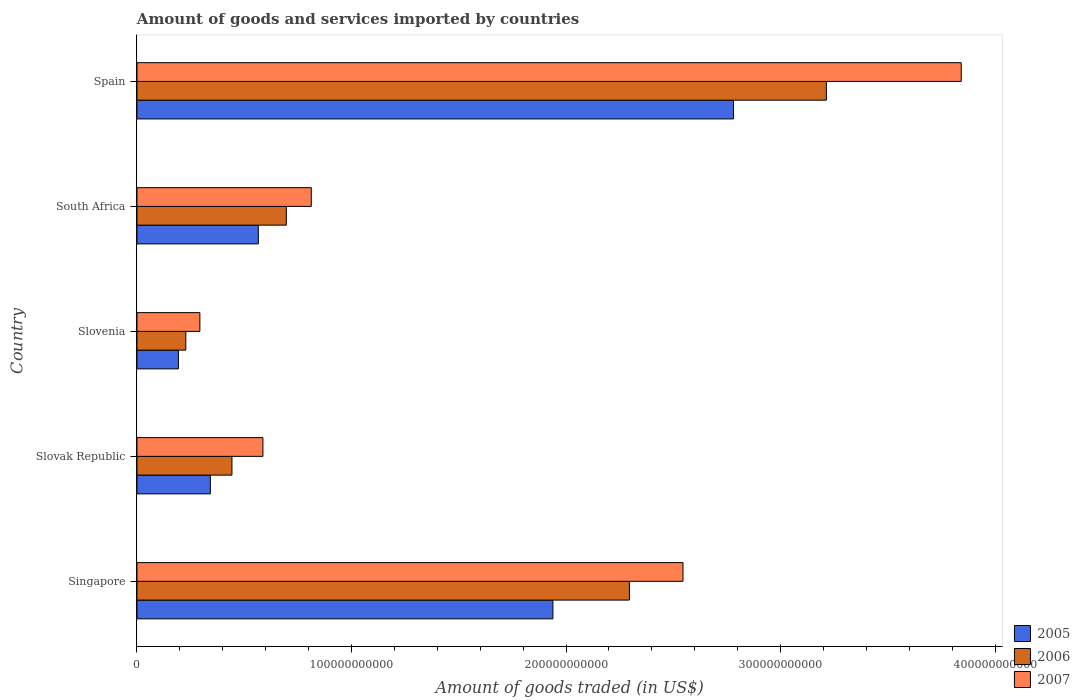How many different coloured bars are there?
Your answer should be compact. 3. Are the number of bars per tick equal to the number of legend labels?
Give a very brief answer. Yes. Are the number of bars on each tick of the Y-axis equal?
Keep it short and to the point. Yes. How many bars are there on the 4th tick from the top?
Offer a very short reply. 3. How many bars are there on the 4th tick from the bottom?
Keep it short and to the point. 3. What is the label of the 2nd group of bars from the top?
Provide a short and direct response. South Africa. In how many cases, is the number of bars for a given country not equal to the number of legend labels?
Offer a terse response. 0. What is the total amount of goods and services imported in 2007 in South Africa?
Provide a short and direct response. 8.13e+1. Across all countries, what is the maximum total amount of goods and services imported in 2005?
Provide a short and direct response. 2.78e+11. Across all countries, what is the minimum total amount of goods and services imported in 2006?
Offer a very short reply. 2.28e+1. In which country was the total amount of goods and services imported in 2005 maximum?
Make the answer very short. Spain. In which country was the total amount of goods and services imported in 2006 minimum?
Provide a succinct answer. Slovenia. What is the total total amount of goods and services imported in 2007 in the graph?
Your answer should be compact. 8.08e+11. What is the difference between the total amount of goods and services imported in 2006 in Slovak Republic and that in South Africa?
Keep it short and to the point. -2.53e+1. What is the difference between the total amount of goods and services imported in 2005 in Slovak Republic and the total amount of goods and services imported in 2007 in South Africa?
Your answer should be compact. -4.70e+1. What is the average total amount of goods and services imported in 2005 per country?
Your answer should be compact. 1.16e+11. What is the difference between the total amount of goods and services imported in 2005 and total amount of goods and services imported in 2006 in Singapore?
Keep it short and to the point. -3.57e+1. In how many countries, is the total amount of goods and services imported in 2006 greater than 120000000000 US$?
Give a very brief answer. 2. What is the ratio of the total amount of goods and services imported in 2006 in Slovenia to that in South Africa?
Provide a short and direct response. 0.33. What is the difference between the highest and the second highest total amount of goods and services imported in 2007?
Your answer should be compact. 1.30e+11. What is the difference between the highest and the lowest total amount of goods and services imported in 2006?
Make the answer very short. 2.99e+11. In how many countries, is the total amount of goods and services imported in 2006 greater than the average total amount of goods and services imported in 2006 taken over all countries?
Make the answer very short. 2. Is the sum of the total amount of goods and services imported in 2007 in Slovenia and South Africa greater than the maximum total amount of goods and services imported in 2006 across all countries?
Your response must be concise. No. What does the 3rd bar from the bottom in Singapore represents?
Ensure brevity in your answer.  2007. Is it the case that in every country, the sum of the total amount of goods and services imported in 2005 and total amount of goods and services imported in 2006 is greater than the total amount of goods and services imported in 2007?
Provide a short and direct response. Yes. How many bars are there?
Provide a succinct answer. 15. What is the difference between two consecutive major ticks on the X-axis?
Offer a very short reply. 1.00e+11. What is the title of the graph?
Provide a succinct answer. Amount of goods and services imported by countries. What is the label or title of the X-axis?
Provide a short and direct response. Amount of goods traded (in US$). What is the Amount of goods traded (in US$) of 2005 in Singapore?
Offer a very short reply. 1.94e+11. What is the Amount of goods traded (in US$) in 2006 in Singapore?
Your answer should be compact. 2.30e+11. What is the Amount of goods traded (in US$) in 2007 in Singapore?
Make the answer very short. 2.55e+11. What is the Amount of goods traded (in US$) of 2005 in Slovak Republic?
Ensure brevity in your answer.  3.42e+1. What is the Amount of goods traded (in US$) in 2006 in Slovak Republic?
Offer a terse response. 4.43e+1. What is the Amount of goods traded (in US$) of 2007 in Slovak Republic?
Make the answer very short. 5.87e+1. What is the Amount of goods traded (in US$) in 2005 in Slovenia?
Keep it short and to the point. 1.93e+1. What is the Amount of goods traded (in US$) of 2006 in Slovenia?
Your response must be concise. 2.28e+1. What is the Amount of goods traded (in US$) of 2007 in Slovenia?
Keep it short and to the point. 2.93e+1. What is the Amount of goods traded (in US$) of 2005 in South Africa?
Provide a succinct answer. 5.66e+1. What is the Amount of goods traded (in US$) in 2006 in South Africa?
Your answer should be very brief. 6.96e+1. What is the Amount of goods traded (in US$) in 2007 in South Africa?
Offer a terse response. 8.13e+1. What is the Amount of goods traded (in US$) of 2005 in Spain?
Give a very brief answer. 2.78e+11. What is the Amount of goods traded (in US$) of 2006 in Spain?
Provide a succinct answer. 3.21e+11. What is the Amount of goods traded (in US$) in 2007 in Spain?
Offer a very short reply. 3.84e+11. Across all countries, what is the maximum Amount of goods traded (in US$) of 2005?
Offer a very short reply. 2.78e+11. Across all countries, what is the maximum Amount of goods traded (in US$) in 2006?
Keep it short and to the point. 3.21e+11. Across all countries, what is the maximum Amount of goods traded (in US$) of 2007?
Your answer should be compact. 3.84e+11. Across all countries, what is the minimum Amount of goods traded (in US$) in 2005?
Provide a succinct answer. 1.93e+1. Across all countries, what is the minimum Amount of goods traded (in US$) in 2006?
Your answer should be very brief. 2.28e+1. Across all countries, what is the minimum Amount of goods traded (in US$) of 2007?
Your answer should be very brief. 2.93e+1. What is the total Amount of goods traded (in US$) in 2005 in the graph?
Provide a short and direct response. 5.82e+11. What is the total Amount of goods traded (in US$) in 2006 in the graph?
Make the answer very short. 6.88e+11. What is the total Amount of goods traded (in US$) of 2007 in the graph?
Your answer should be compact. 8.08e+11. What is the difference between the Amount of goods traded (in US$) of 2005 in Singapore and that in Slovak Republic?
Provide a short and direct response. 1.60e+11. What is the difference between the Amount of goods traded (in US$) of 2006 in Singapore and that in Slovak Republic?
Keep it short and to the point. 1.85e+11. What is the difference between the Amount of goods traded (in US$) of 2007 in Singapore and that in Slovak Republic?
Ensure brevity in your answer.  1.96e+11. What is the difference between the Amount of goods traded (in US$) in 2005 in Singapore and that in Slovenia?
Make the answer very short. 1.75e+11. What is the difference between the Amount of goods traded (in US$) of 2006 in Singapore and that in Slovenia?
Offer a very short reply. 2.07e+11. What is the difference between the Amount of goods traded (in US$) in 2007 in Singapore and that in Slovenia?
Your answer should be very brief. 2.25e+11. What is the difference between the Amount of goods traded (in US$) of 2005 in Singapore and that in South Africa?
Offer a terse response. 1.37e+11. What is the difference between the Amount of goods traded (in US$) of 2006 in Singapore and that in South Africa?
Ensure brevity in your answer.  1.60e+11. What is the difference between the Amount of goods traded (in US$) in 2007 in Singapore and that in South Africa?
Make the answer very short. 1.73e+11. What is the difference between the Amount of goods traded (in US$) in 2005 in Singapore and that in Spain?
Keep it short and to the point. -8.42e+1. What is the difference between the Amount of goods traded (in US$) in 2006 in Singapore and that in Spain?
Your answer should be very brief. -9.18e+1. What is the difference between the Amount of goods traded (in US$) of 2007 in Singapore and that in Spain?
Your answer should be compact. -1.30e+11. What is the difference between the Amount of goods traded (in US$) in 2005 in Slovak Republic and that in Slovenia?
Provide a succinct answer. 1.49e+1. What is the difference between the Amount of goods traded (in US$) in 2006 in Slovak Republic and that in Slovenia?
Your answer should be very brief. 2.15e+1. What is the difference between the Amount of goods traded (in US$) of 2007 in Slovak Republic and that in Slovenia?
Keep it short and to the point. 2.94e+1. What is the difference between the Amount of goods traded (in US$) in 2005 in Slovak Republic and that in South Africa?
Offer a terse response. -2.24e+1. What is the difference between the Amount of goods traded (in US$) in 2006 in Slovak Republic and that in South Africa?
Provide a succinct answer. -2.53e+1. What is the difference between the Amount of goods traded (in US$) in 2007 in Slovak Republic and that in South Africa?
Your response must be concise. -2.25e+1. What is the difference between the Amount of goods traded (in US$) of 2005 in Slovak Republic and that in Spain?
Provide a short and direct response. -2.44e+11. What is the difference between the Amount of goods traded (in US$) in 2006 in Slovak Republic and that in Spain?
Offer a terse response. -2.77e+11. What is the difference between the Amount of goods traded (in US$) in 2007 in Slovak Republic and that in Spain?
Your answer should be very brief. -3.26e+11. What is the difference between the Amount of goods traded (in US$) of 2005 in Slovenia and that in South Africa?
Your answer should be very brief. -3.72e+1. What is the difference between the Amount of goods traded (in US$) in 2006 in Slovenia and that in South Africa?
Provide a succinct answer. -4.69e+1. What is the difference between the Amount of goods traded (in US$) in 2007 in Slovenia and that in South Africa?
Your answer should be very brief. -5.19e+1. What is the difference between the Amount of goods traded (in US$) of 2005 in Slovenia and that in Spain?
Offer a terse response. -2.59e+11. What is the difference between the Amount of goods traded (in US$) in 2006 in Slovenia and that in Spain?
Give a very brief answer. -2.99e+11. What is the difference between the Amount of goods traded (in US$) in 2007 in Slovenia and that in Spain?
Ensure brevity in your answer.  -3.55e+11. What is the difference between the Amount of goods traded (in US$) in 2005 in South Africa and that in Spain?
Keep it short and to the point. -2.22e+11. What is the difference between the Amount of goods traded (in US$) of 2006 in South Africa and that in Spain?
Keep it short and to the point. -2.52e+11. What is the difference between the Amount of goods traded (in US$) of 2007 in South Africa and that in Spain?
Your answer should be very brief. -3.03e+11. What is the difference between the Amount of goods traded (in US$) in 2005 in Singapore and the Amount of goods traded (in US$) in 2006 in Slovak Republic?
Your answer should be compact. 1.50e+11. What is the difference between the Amount of goods traded (in US$) of 2005 in Singapore and the Amount of goods traded (in US$) of 2007 in Slovak Republic?
Ensure brevity in your answer.  1.35e+11. What is the difference between the Amount of goods traded (in US$) of 2006 in Singapore and the Amount of goods traded (in US$) of 2007 in Slovak Republic?
Provide a succinct answer. 1.71e+11. What is the difference between the Amount of goods traded (in US$) of 2005 in Singapore and the Amount of goods traded (in US$) of 2006 in Slovenia?
Make the answer very short. 1.71e+11. What is the difference between the Amount of goods traded (in US$) in 2005 in Singapore and the Amount of goods traded (in US$) in 2007 in Slovenia?
Your answer should be very brief. 1.65e+11. What is the difference between the Amount of goods traded (in US$) in 2006 in Singapore and the Amount of goods traded (in US$) in 2007 in Slovenia?
Ensure brevity in your answer.  2.00e+11. What is the difference between the Amount of goods traded (in US$) in 2005 in Singapore and the Amount of goods traded (in US$) in 2006 in South Africa?
Your answer should be very brief. 1.24e+11. What is the difference between the Amount of goods traded (in US$) in 2005 in Singapore and the Amount of goods traded (in US$) in 2007 in South Africa?
Your answer should be compact. 1.13e+11. What is the difference between the Amount of goods traded (in US$) in 2006 in Singapore and the Amount of goods traded (in US$) in 2007 in South Africa?
Offer a very short reply. 1.48e+11. What is the difference between the Amount of goods traded (in US$) of 2005 in Singapore and the Amount of goods traded (in US$) of 2006 in Spain?
Provide a short and direct response. -1.27e+11. What is the difference between the Amount of goods traded (in US$) in 2005 in Singapore and the Amount of goods traded (in US$) in 2007 in Spain?
Give a very brief answer. -1.90e+11. What is the difference between the Amount of goods traded (in US$) of 2006 in Singapore and the Amount of goods traded (in US$) of 2007 in Spain?
Your answer should be compact. -1.55e+11. What is the difference between the Amount of goods traded (in US$) in 2005 in Slovak Republic and the Amount of goods traded (in US$) in 2006 in Slovenia?
Your response must be concise. 1.14e+1. What is the difference between the Amount of goods traded (in US$) of 2005 in Slovak Republic and the Amount of goods traded (in US$) of 2007 in Slovenia?
Your response must be concise. 4.88e+09. What is the difference between the Amount of goods traded (in US$) in 2006 in Slovak Republic and the Amount of goods traded (in US$) in 2007 in Slovenia?
Your answer should be compact. 1.50e+1. What is the difference between the Amount of goods traded (in US$) in 2005 in Slovak Republic and the Amount of goods traded (in US$) in 2006 in South Africa?
Your response must be concise. -3.54e+1. What is the difference between the Amount of goods traded (in US$) in 2005 in Slovak Republic and the Amount of goods traded (in US$) in 2007 in South Africa?
Your answer should be compact. -4.70e+1. What is the difference between the Amount of goods traded (in US$) in 2006 in Slovak Republic and the Amount of goods traded (in US$) in 2007 in South Africa?
Provide a succinct answer. -3.70e+1. What is the difference between the Amount of goods traded (in US$) of 2005 in Slovak Republic and the Amount of goods traded (in US$) of 2006 in Spain?
Offer a terse response. -2.87e+11. What is the difference between the Amount of goods traded (in US$) of 2005 in Slovak Republic and the Amount of goods traded (in US$) of 2007 in Spain?
Give a very brief answer. -3.50e+11. What is the difference between the Amount of goods traded (in US$) in 2006 in Slovak Republic and the Amount of goods traded (in US$) in 2007 in Spain?
Make the answer very short. -3.40e+11. What is the difference between the Amount of goods traded (in US$) in 2005 in Slovenia and the Amount of goods traded (in US$) in 2006 in South Africa?
Make the answer very short. -5.03e+1. What is the difference between the Amount of goods traded (in US$) of 2005 in Slovenia and the Amount of goods traded (in US$) of 2007 in South Africa?
Make the answer very short. -6.19e+1. What is the difference between the Amount of goods traded (in US$) in 2006 in Slovenia and the Amount of goods traded (in US$) in 2007 in South Africa?
Your answer should be very brief. -5.85e+1. What is the difference between the Amount of goods traded (in US$) of 2005 in Slovenia and the Amount of goods traded (in US$) of 2006 in Spain?
Your response must be concise. -3.02e+11. What is the difference between the Amount of goods traded (in US$) in 2005 in Slovenia and the Amount of goods traded (in US$) in 2007 in Spain?
Offer a terse response. -3.65e+11. What is the difference between the Amount of goods traded (in US$) of 2006 in Slovenia and the Amount of goods traded (in US$) of 2007 in Spain?
Provide a succinct answer. -3.61e+11. What is the difference between the Amount of goods traded (in US$) in 2005 in South Africa and the Amount of goods traded (in US$) in 2006 in Spain?
Keep it short and to the point. -2.65e+11. What is the difference between the Amount of goods traded (in US$) of 2005 in South Africa and the Amount of goods traded (in US$) of 2007 in Spain?
Keep it short and to the point. -3.28e+11. What is the difference between the Amount of goods traded (in US$) of 2006 in South Africa and the Amount of goods traded (in US$) of 2007 in Spain?
Give a very brief answer. -3.15e+11. What is the average Amount of goods traded (in US$) in 2005 per country?
Offer a very short reply. 1.16e+11. What is the average Amount of goods traded (in US$) of 2006 per country?
Offer a very short reply. 1.38e+11. What is the average Amount of goods traded (in US$) of 2007 per country?
Your response must be concise. 1.62e+11. What is the difference between the Amount of goods traded (in US$) in 2005 and Amount of goods traded (in US$) in 2006 in Singapore?
Your answer should be compact. -3.57e+1. What is the difference between the Amount of goods traded (in US$) of 2005 and Amount of goods traded (in US$) of 2007 in Singapore?
Your response must be concise. -6.06e+1. What is the difference between the Amount of goods traded (in US$) in 2006 and Amount of goods traded (in US$) in 2007 in Singapore?
Provide a succinct answer. -2.50e+1. What is the difference between the Amount of goods traded (in US$) in 2005 and Amount of goods traded (in US$) in 2006 in Slovak Republic?
Provide a succinct answer. -1.01e+1. What is the difference between the Amount of goods traded (in US$) of 2005 and Amount of goods traded (in US$) of 2007 in Slovak Republic?
Your answer should be compact. -2.45e+1. What is the difference between the Amount of goods traded (in US$) of 2006 and Amount of goods traded (in US$) of 2007 in Slovak Republic?
Keep it short and to the point. -1.44e+1. What is the difference between the Amount of goods traded (in US$) of 2005 and Amount of goods traded (in US$) of 2006 in Slovenia?
Give a very brief answer. -3.45e+09. What is the difference between the Amount of goods traded (in US$) of 2005 and Amount of goods traded (in US$) of 2007 in Slovenia?
Provide a short and direct response. -1.00e+1. What is the difference between the Amount of goods traded (in US$) of 2006 and Amount of goods traded (in US$) of 2007 in Slovenia?
Offer a terse response. -6.56e+09. What is the difference between the Amount of goods traded (in US$) in 2005 and Amount of goods traded (in US$) in 2006 in South Africa?
Provide a succinct answer. -1.31e+1. What is the difference between the Amount of goods traded (in US$) of 2005 and Amount of goods traded (in US$) of 2007 in South Africa?
Make the answer very short. -2.47e+1. What is the difference between the Amount of goods traded (in US$) in 2006 and Amount of goods traded (in US$) in 2007 in South Africa?
Your response must be concise. -1.16e+1. What is the difference between the Amount of goods traded (in US$) of 2005 and Amount of goods traded (in US$) of 2006 in Spain?
Your answer should be compact. -4.33e+1. What is the difference between the Amount of goods traded (in US$) in 2005 and Amount of goods traded (in US$) in 2007 in Spain?
Make the answer very short. -1.06e+11. What is the difference between the Amount of goods traded (in US$) of 2006 and Amount of goods traded (in US$) of 2007 in Spain?
Offer a terse response. -6.29e+1. What is the ratio of the Amount of goods traded (in US$) of 2005 in Singapore to that in Slovak Republic?
Provide a short and direct response. 5.67. What is the ratio of the Amount of goods traded (in US$) of 2006 in Singapore to that in Slovak Republic?
Provide a short and direct response. 5.18. What is the ratio of the Amount of goods traded (in US$) of 2007 in Singapore to that in Slovak Republic?
Give a very brief answer. 4.34. What is the ratio of the Amount of goods traded (in US$) of 2005 in Singapore to that in Slovenia?
Your answer should be compact. 10.03. What is the ratio of the Amount of goods traded (in US$) of 2006 in Singapore to that in Slovenia?
Offer a terse response. 10.08. What is the ratio of the Amount of goods traded (in US$) in 2007 in Singapore to that in Slovenia?
Your answer should be very brief. 8.68. What is the ratio of the Amount of goods traded (in US$) of 2005 in Singapore to that in South Africa?
Offer a very short reply. 3.43. What is the ratio of the Amount of goods traded (in US$) of 2006 in Singapore to that in South Africa?
Your answer should be very brief. 3.3. What is the ratio of the Amount of goods traded (in US$) in 2007 in Singapore to that in South Africa?
Keep it short and to the point. 3.13. What is the ratio of the Amount of goods traded (in US$) in 2005 in Singapore to that in Spain?
Provide a short and direct response. 0.7. What is the ratio of the Amount of goods traded (in US$) in 2006 in Singapore to that in Spain?
Ensure brevity in your answer.  0.71. What is the ratio of the Amount of goods traded (in US$) of 2007 in Singapore to that in Spain?
Give a very brief answer. 0.66. What is the ratio of the Amount of goods traded (in US$) of 2005 in Slovak Republic to that in Slovenia?
Your response must be concise. 1.77. What is the ratio of the Amount of goods traded (in US$) in 2006 in Slovak Republic to that in Slovenia?
Provide a short and direct response. 1.94. What is the ratio of the Amount of goods traded (in US$) in 2007 in Slovak Republic to that in Slovenia?
Offer a very short reply. 2. What is the ratio of the Amount of goods traded (in US$) in 2005 in Slovak Republic to that in South Africa?
Offer a very short reply. 0.6. What is the ratio of the Amount of goods traded (in US$) in 2006 in Slovak Republic to that in South Africa?
Make the answer very short. 0.64. What is the ratio of the Amount of goods traded (in US$) in 2007 in Slovak Republic to that in South Africa?
Ensure brevity in your answer.  0.72. What is the ratio of the Amount of goods traded (in US$) in 2005 in Slovak Republic to that in Spain?
Ensure brevity in your answer.  0.12. What is the ratio of the Amount of goods traded (in US$) in 2006 in Slovak Republic to that in Spain?
Provide a short and direct response. 0.14. What is the ratio of the Amount of goods traded (in US$) in 2007 in Slovak Republic to that in Spain?
Provide a succinct answer. 0.15. What is the ratio of the Amount of goods traded (in US$) of 2005 in Slovenia to that in South Africa?
Give a very brief answer. 0.34. What is the ratio of the Amount of goods traded (in US$) in 2006 in Slovenia to that in South Africa?
Your answer should be compact. 0.33. What is the ratio of the Amount of goods traded (in US$) in 2007 in Slovenia to that in South Africa?
Ensure brevity in your answer.  0.36. What is the ratio of the Amount of goods traded (in US$) of 2005 in Slovenia to that in Spain?
Provide a succinct answer. 0.07. What is the ratio of the Amount of goods traded (in US$) of 2006 in Slovenia to that in Spain?
Give a very brief answer. 0.07. What is the ratio of the Amount of goods traded (in US$) of 2007 in Slovenia to that in Spain?
Your answer should be very brief. 0.08. What is the ratio of the Amount of goods traded (in US$) of 2005 in South Africa to that in Spain?
Ensure brevity in your answer.  0.2. What is the ratio of the Amount of goods traded (in US$) of 2006 in South Africa to that in Spain?
Keep it short and to the point. 0.22. What is the ratio of the Amount of goods traded (in US$) of 2007 in South Africa to that in Spain?
Your answer should be very brief. 0.21. What is the difference between the highest and the second highest Amount of goods traded (in US$) of 2005?
Your response must be concise. 8.42e+1. What is the difference between the highest and the second highest Amount of goods traded (in US$) in 2006?
Provide a succinct answer. 9.18e+1. What is the difference between the highest and the second highest Amount of goods traded (in US$) in 2007?
Offer a terse response. 1.30e+11. What is the difference between the highest and the lowest Amount of goods traded (in US$) in 2005?
Make the answer very short. 2.59e+11. What is the difference between the highest and the lowest Amount of goods traded (in US$) in 2006?
Your answer should be very brief. 2.99e+11. What is the difference between the highest and the lowest Amount of goods traded (in US$) of 2007?
Give a very brief answer. 3.55e+11. 